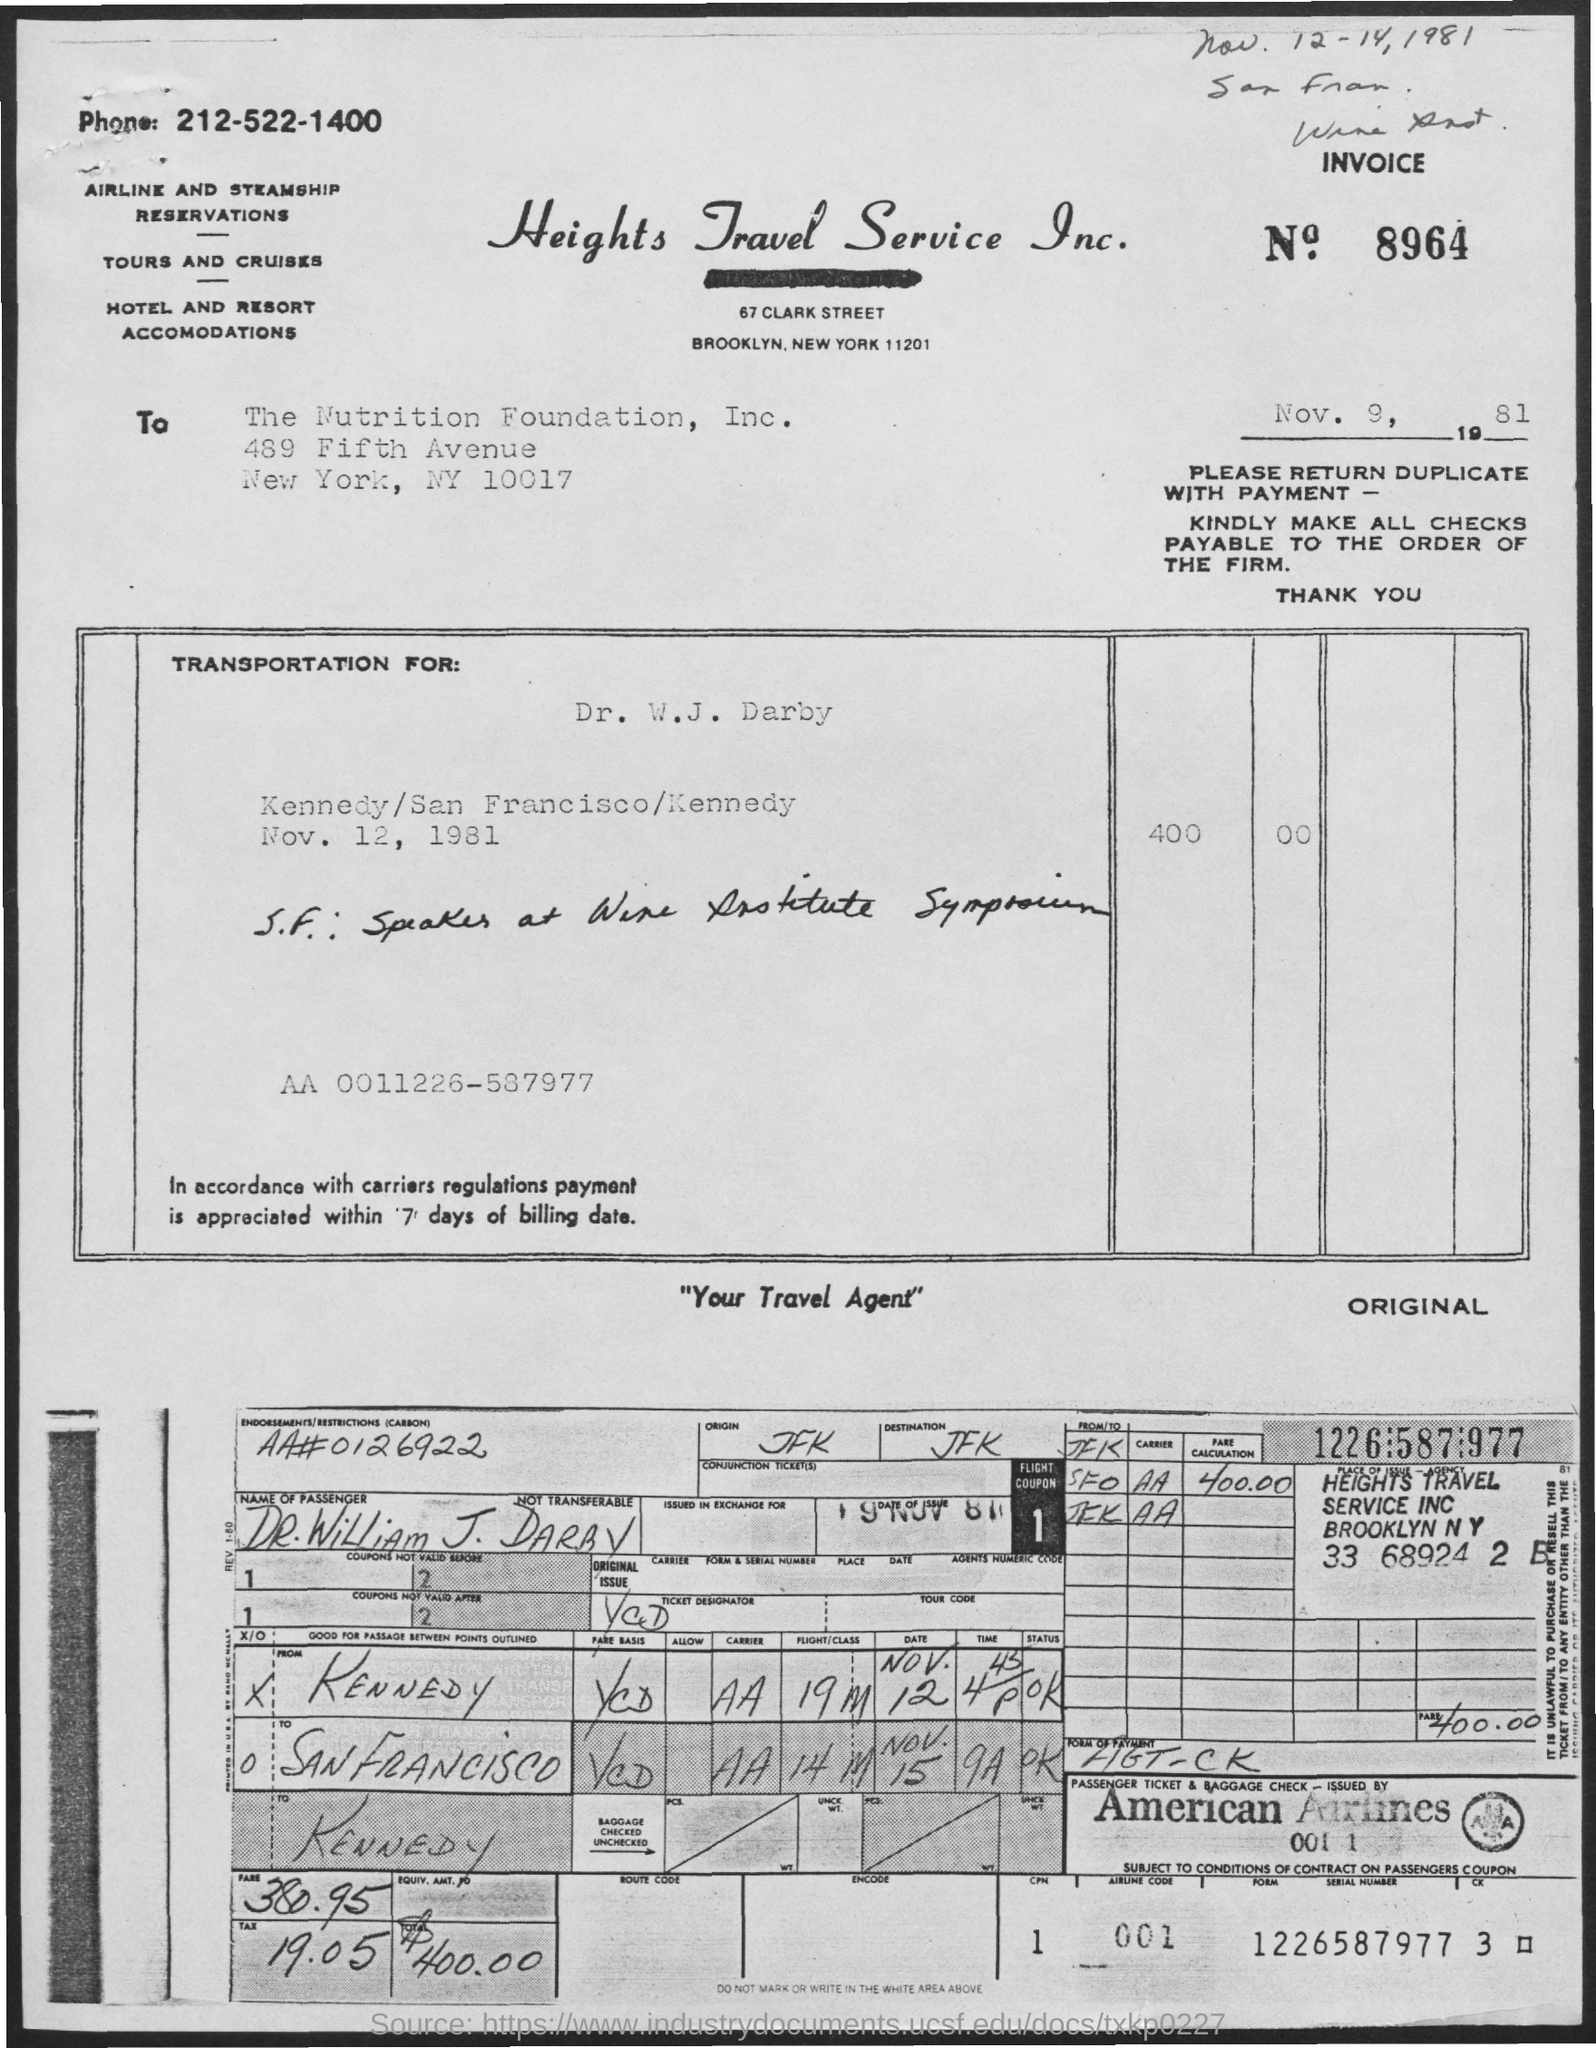Point out several critical features in this image. The invoice number is 8964... The tax is 19.05.. The serial number is 1226587977. The date listed below the invoice number is November 9, 1981. 